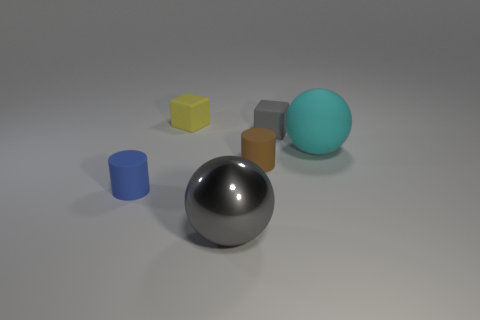Is there a brown cylinder of the same size as the gray matte block?
Give a very brief answer. Yes. How many objects are tiny blocks that are on the right side of the large gray thing or tiny things?
Provide a succinct answer. 4. Do the gray cube and the cube that is behind the small gray matte thing have the same material?
Provide a succinct answer. Yes. What number of other objects are the same shape as the tiny gray rubber thing?
Provide a succinct answer. 1. What number of objects are either gray metal spheres that are right of the tiny blue cylinder or tiny rubber objects that are behind the small gray matte block?
Keep it short and to the point. 2. What number of other objects are the same color as the large rubber sphere?
Provide a succinct answer. 0. Is the number of small yellow blocks on the right side of the yellow matte object less than the number of tiny matte things that are in front of the brown thing?
Your answer should be compact. Yes. How many big gray cylinders are there?
Your answer should be compact. 0. Are there any other things that have the same material as the large gray ball?
Provide a succinct answer. No. There is a large gray object that is the same shape as the large cyan rubber object; what is it made of?
Your answer should be compact. Metal. 